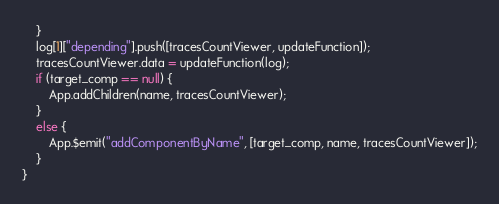Convert code to text. <code><loc_0><loc_0><loc_500><loc_500><_JavaScript_>    }
    log[1]["depending"].push([tracesCountViewer, updateFunction]);
    tracesCountViewer.data = updateFunction(log);
    if (target_comp == null) {
        App.addChildren(name, tracesCountViewer);
    }
    else {
        App.$emit("addComponentByName", [target_comp, name, tracesCountViewer]);
    }
}
</code> 